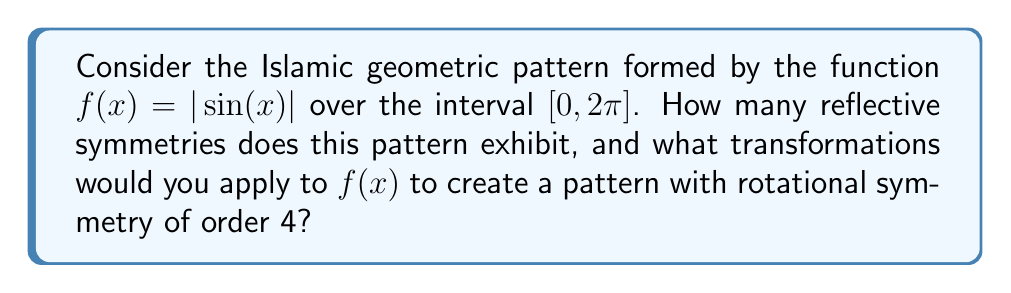What is the answer to this math problem? 1. Analyze the reflective symmetry of $f(x) = |\sin(x)|$ over $[0, 2\pi]$:
   - The function is symmetric about the y-axis (x = 0)
   - It's also symmetric about x = $\pi$
   - There are two vertical lines of symmetry at x = $\frac{\pi}{2}$ and x = $\frac{3\pi}{2}$

   Total reflective symmetries: 4

2. To create a pattern with rotational symmetry of order 4:
   a) First, we need to compress the function horizontally by a factor of 2:
      $g(x) = f(2x) = |\sin(2x)|$

   b) Then, we create four copies of this function rotated by 90°, 180°, and 270°:
      $h_1(x,y) = g(x)$
      $h_2(x,y) = g(y)$
      $h_3(x,y) = g(-x)$
      $h_4(x,y) = g(-y)$

   c) The final function with rotational symmetry of order 4 is:
      $H(x,y) = \max(h_1(x,y), h_2(x,y), h_3(x,y), h_4(x,y))$

   This creates a pattern that repeats every 90° rotation, giving it rotational symmetry of order 4.
Answer: 4 reflective symmetries; $H(x,y) = \max(|\sin(2x)|, |\sin(2y)|, |\sin(-2x)|, |\sin(-2y)|)$ 